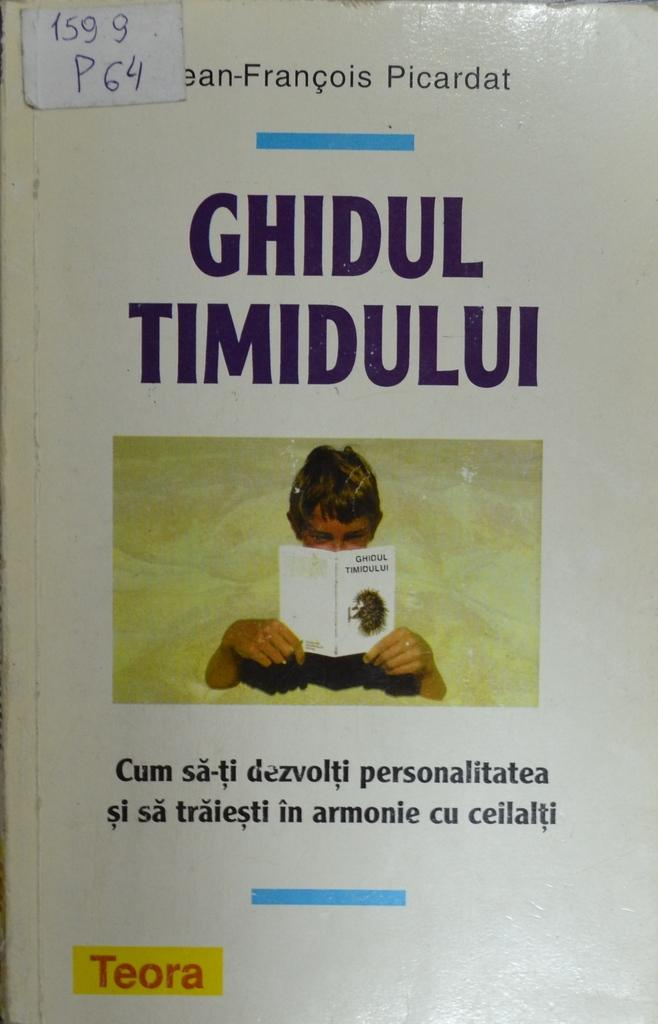<image>
Describe the image concisely. A white book with a person on the front, titled ghidul Timidului 